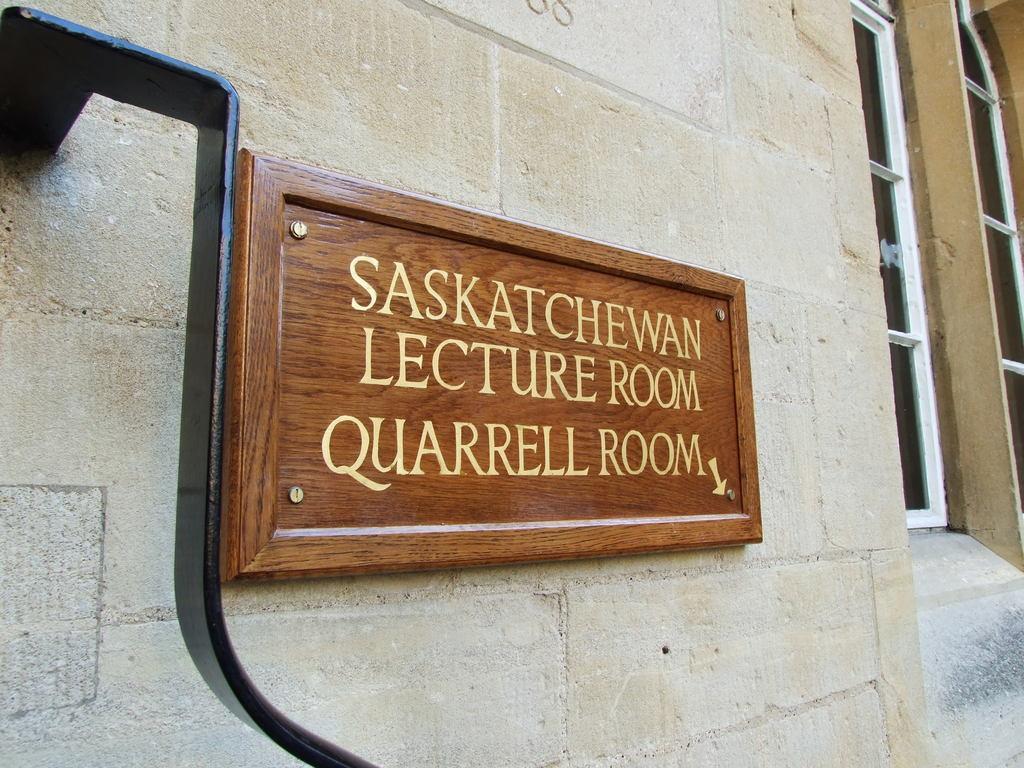Can you describe this image briefly? In this image there is a name board attached to the wall having windows. Left side there is a metal rod attached to the wall. 